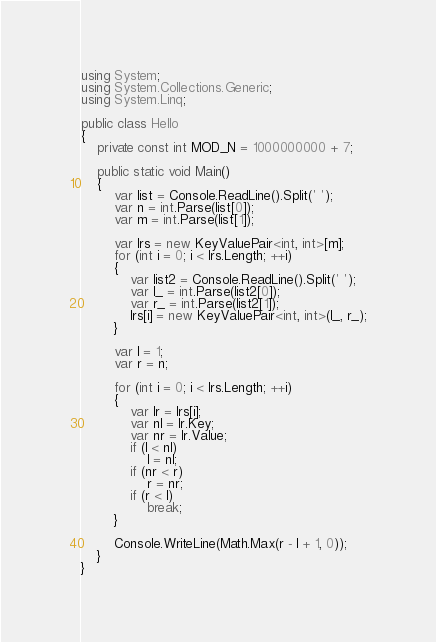Convert code to text. <code><loc_0><loc_0><loc_500><loc_500><_C#_>using System;
using System.Collections.Generic;
using System.Linq;

public class Hello
{
    private const int MOD_N = 1000000000 + 7;

    public static void Main()
    {
        var list = Console.ReadLine().Split(' ');
        var n = int.Parse(list[0]);
        var m = int.Parse(list[1]);

        var lrs = new KeyValuePair<int, int>[m];
        for (int i = 0; i < lrs.Length; ++i)
        {
            var list2 = Console.ReadLine().Split(' ');
            var l_ = int.Parse(list2[0]);
            var r_ = int.Parse(list2[1]);
            lrs[i] = new KeyValuePair<int, int>(l_, r_);
        }

        var l = 1;
        var r = n;

        for (int i = 0; i < lrs.Length; ++i)
        {
            var lr = lrs[i];
            var nl = lr.Key;
            var nr = lr.Value;
            if (l < nl)
                l = nl;
            if (nr < r)
                r = nr;
            if (r < l)
                break;
        }

        Console.WriteLine(Math.Max(r - l + 1, 0));
    }
}
</code> 